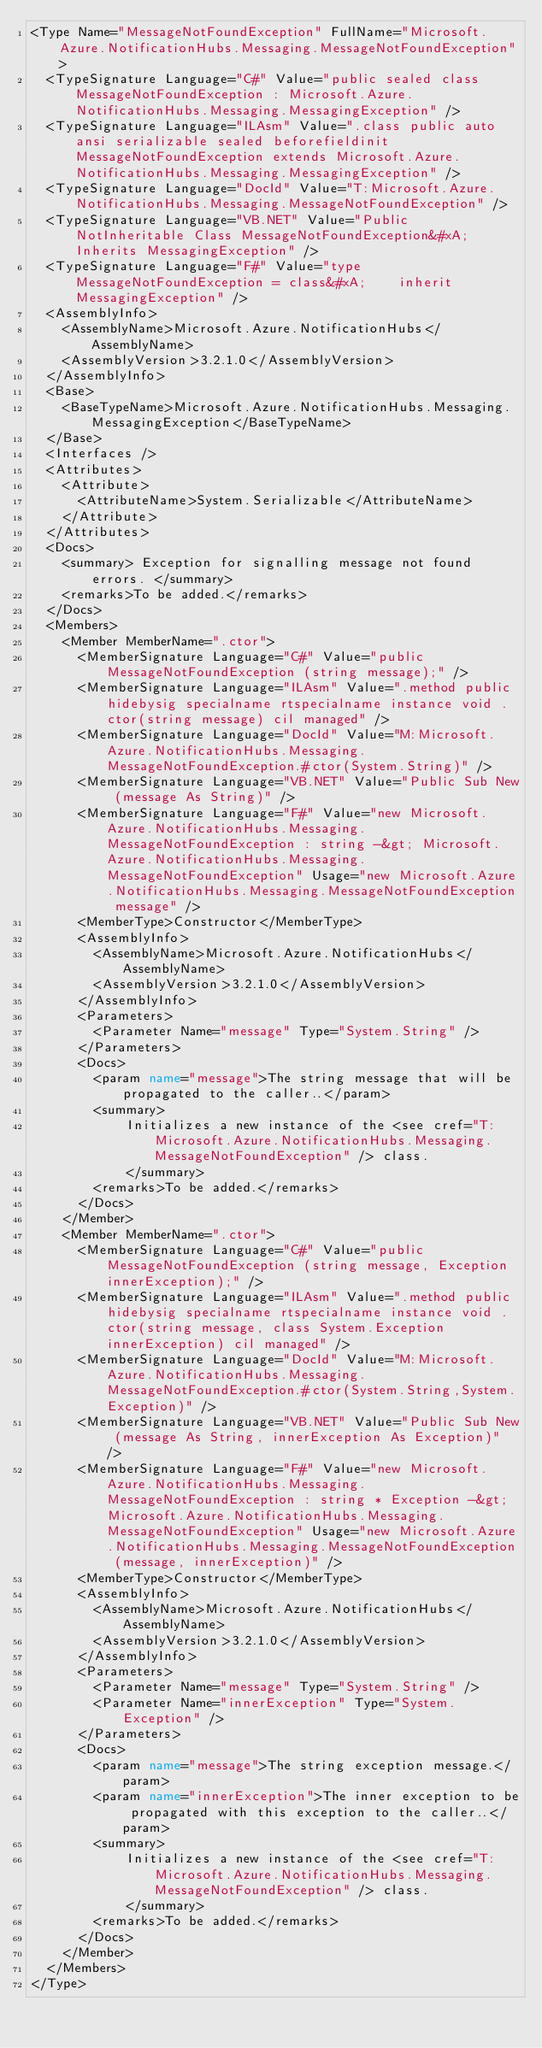Convert code to text. <code><loc_0><loc_0><loc_500><loc_500><_XML_><Type Name="MessageNotFoundException" FullName="Microsoft.Azure.NotificationHubs.Messaging.MessageNotFoundException">
  <TypeSignature Language="C#" Value="public sealed class MessageNotFoundException : Microsoft.Azure.NotificationHubs.Messaging.MessagingException" />
  <TypeSignature Language="ILAsm" Value=".class public auto ansi serializable sealed beforefieldinit MessageNotFoundException extends Microsoft.Azure.NotificationHubs.Messaging.MessagingException" />
  <TypeSignature Language="DocId" Value="T:Microsoft.Azure.NotificationHubs.Messaging.MessageNotFoundException" />
  <TypeSignature Language="VB.NET" Value="Public NotInheritable Class MessageNotFoundException&#xA;Inherits MessagingException" />
  <TypeSignature Language="F#" Value="type MessageNotFoundException = class&#xA;    inherit MessagingException" />
  <AssemblyInfo>
    <AssemblyName>Microsoft.Azure.NotificationHubs</AssemblyName>
    <AssemblyVersion>3.2.1.0</AssemblyVersion>
  </AssemblyInfo>
  <Base>
    <BaseTypeName>Microsoft.Azure.NotificationHubs.Messaging.MessagingException</BaseTypeName>
  </Base>
  <Interfaces />
  <Attributes>
    <Attribute>
      <AttributeName>System.Serializable</AttributeName>
    </Attribute>
  </Attributes>
  <Docs>
    <summary> Exception for signalling message not found errors. </summary>
    <remarks>To be added.</remarks>
  </Docs>
  <Members>
    <Member MemberName=".ctor">
      <MemberSignature Language="C#" Value="public MessageNotFoundException (string message);" />
      <MemberSignature Language="ILAsm" Value=".method public hidebysig specialname rtspecialname instance void .ctor(string message) cil managed" />
      <MemberSignature Language="DocId" Value="M:Microsoft.Azure.NotificationHubs.Messaging.MessageNotFoundException.#ctor(System.String)" />
      <MemberSignature Language="VB.NET" Value="Public Sub New (message As String)" />
      <MemberSignature Language="F#" Value="new Microsoft.Azure.NotificationHubs.Messaging.MessageNotFoundException : string -&gt; Microsoft.Azure.NotificationHubs.Messaging.MessageNotFoundException" Usage="new Microsoft.Azure.NotificationHubs.Messaging.MessageNotFoundException message" />
      <MemberType>Constructor</MemberType>
      <AssemblyInfo>
        <AssemblyName>Microsoft.Azure.NotificationHubs</AssemblyName>
        <AssemblyVersion>3.2.1.0</AssemblyVersion>
      </AssemblyInfo>
      <Parameters>
        <Parameter Name="message" Type="System.String" />
      </Parameters>
      <Docs>
        <param name="message">The string message that will be propagated to the caller..</param>
        <summary>
            Initializes a new instance of the <see cref="T:Microsoft.Azure.NotificationHubs.Messaging.MessageNotFoundException" /> class.
            </summary>
        <remarks>To be added.</remarks>
      </Docs>
    </Member>
    <Member MemberName=".ctor">
      <MemberSignature Language="C#" Value="public MessageNotFoundException (string message, Exception innerException);" />
      <MemberSignature Language="ILAsm" Value=".method public hidebysig specialname rtspecialname instance void .ctor(string message, class System.Exception innerException) cil managed" />
      <MemberSignature Language="DocId" Value="M:Microsoft.Azure.NotificationHubs.Messaging.MessageNotFoundException.#ctor(System.String,System.Exception)" />
      <MemberSignature Language="VB.NET" Value="Public Sub New (message As String, innerException As Exception)" />
      <MemberSignature Language="F#" Value="new Microsoft.Azure.NotificationHubs.Messaging.MessageNotFoundException : string * Exception -&gt; Microsoft.Azure.NotificationHubs.Messaging.MessageNotFoundException" Usage="new Microsoft.Azure.NotificationHubs.Messaging.MessageNotFoundException (message, innerException)" />
      <MemberType>Constructor</MemberType>
      <AssemblyInfo>
        <AssemblyName>Microsoft.Azure.NotificationHubs</AssemblyName>
        <AssemblyVersion>3.2.1.0</AssemblyVersion>
      </AssemblyInfo>
      <Parameters>
        <Parameter Name="message" Type="System.String" />
        <Parameter Name="innerException" Type="System.Exception" />
      </Parameters>
      <Docs>
        <param name="message">The string exception message.</param>
        <param name="innerException">The inner exception to be propagated with this exception to the caller..</param>
        <summary>
            Initializes a new instance of the <see cref="T:Microsoft.Azure.NotificationHubs.Messaging.MessageNotFoundException" /> class.
            </summary>
        <remarks>To be added.</remarks>
      </Docs>
    </Member>
  </Members>
</Type>
</code> 